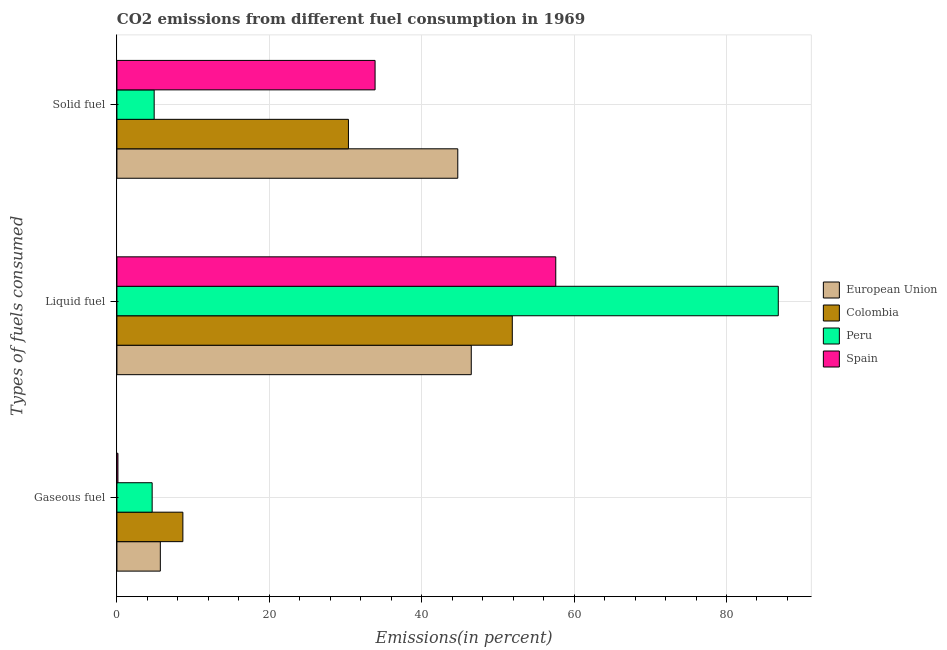How many different coloured bars are there?
Keep it short and to the point. 4. How many groups of bars are there?
Provide a short and direct response. 3. Are the number of bars on each tick of the Y-axis equal?
Your answer should be compact. Yes. How many bars are there on the 3rd tick from the top?
Make the answer very short. 4. What is the label of the 2nd group of bars from the top?
Provide a succinct answer. Liquid fuel. What is the percentage of gaseous fuel emission in European Union?
Offer a terse response. 5.7. Across all countries, what is the maximum percentage of gaseous fuel emission?
Give a very brief answer. 8.65. Across all countries, what is the minimum percentage of liquid fuel emission?
Give a very brief answer. 46.5. What is the total percentage of solid fuel emission in the graph?
Your answer should be very brief. 113.88. What is the difference between the percentage of liquid fuel emission in Colombia and that in Spain?
Provide a succinct answer. -5.7. What is the difference between the percentage of gaseous fuel emission in Colombia and the percentage of liquid fuel emission in Spain?
Provide a succinct answer. -48.94. What is the average percentage of liquid fuel emission per country?
Give a very brief answer. 60.7. What is the difference between the percentage of liquid fuel emission and percentage of gaseous fuel emission in European Union?
Provide a short and direct response. 40.81. In how many countries, is the percentage of liquid fuel emission greater than 32 %?
Give a very brief answer. 4. What is the ratio of the percentage of solid fuel emission in Colombia to that in European Union?
Make the answer very short. 0.68. Is the percentage of solid fuel emission in Peru less than that in European Union?
Your answer should be compact. Yes. What is the difference between the highest and the second highest percentage of liquid fuel emission?
Ensure brevity in your answer.  29.2. What is the difference between the highest and the lowest percentage of liquid fuel emission?
Your response must be concise. 40.29. Is the sum of the percentage of solid fuel emission in Peru and Colombia greater than the maximum percentage of gaseous fuel emission across all countries?
Your response must be concise. Yes. What does the 4th bar from the top in Liquid fuel represents?
Provide a short and direct response. European Union. What does the 1st bar from the bottom in Gaseous fuel represents?
Provide a succinct answer. European Union. Is it the case that in every country, the sum of the percentage of gaseous fuel emission and percentage of liquid fuel emission is greater than the percentage of solid fuel emission?
Offer a very short reply. Yes. Are all the bars in the graph horizontal?
Provide a short and direct response. Yes. What is the difference between two consecutive major ticks on the X-axis?
Provide a succinct answer. 20. Are the values on the major ticks of X-axis written in scientific E-notation?
Your response must be concise. No. Does the graph contain grids?
Provide a succinct answer. Yes. How many legend labels are there?
Give a very brief answer. 4. What is the title of the graph?
Provide a short and direct response. CO2 emissions from different fuel consumption in 1969. What is the label or title of the X-axis?
Ensure brevity in your answer.  Emissions(in percent). What is the label or title of the Y-axis?
Keep it short and to the point. Types of fuels consumed. What is the Emissions(in percent) of European Union in Gaseous fuel?
Provide a short and direct response. 5.7. What is the Emissions(in percent) of Colombia in Gaseous fuel?
Provide a short and direct response. 8.65. What is the Emissions(in percent) of Peru in Gaseous fuel?
Provide a short and direct response. 4.62. What is the Emissions(in percent) of Spain in Gaseous fuel?
Provide a short and direct response. 0.13. What is the Emissions(in percent) of European Union in Liquid fuel?
Ensure brevity in your answer.  46.5. What is the Emissions(in percent) of Colombia in Liquid fuel?
Make the answer very short. 51.89. What is the Emissions(in percent) in Peru in Liquid fuel?
Offer a terse response. 86.8. What is the Emissions(in percent) of Spain in Liquid fuel?
Provide a succinct answer. 57.59. What is the Emissions(in percent) in European Union in Solid fuel?
Offer a very short reply. 44.73. What is the Emissions(in percent) in Colombia in Solid fuel?
Keep it short and to the point. 30.38. What is the Emissions(in percent) in Peru in Solid fuel?
Your response must be concise. 4.89. What is the Emissions(in percent) in Spain in Solid fuel?
Offer a very short reply. 33.88. Across all Types of fuels consumed, what is the maximum Emissions(in percent) in European Union?
Your answer should be compact. 46.5. Across all Types of fuels consumed, what is the maximum Emissions(in percent) of Colombia?
Offer a terse response. 51.89. Across all Types of fuels consumed, what is the maximum Emissions(in percent) of Peru?
Provide a succinct answer. 86.8. Across all Types of fuels consumed, what is the maximum Emissions(in percent) of Spain?
Offer a very short reply. 57.59. Across all Types of fuels consumed, what is the minimum Emissions(in percent) of European Union?
Provide a succinct answer. 5.7. Across all Types of fuels consumed, what is the minimum Emissions(in percent) in Colombia?
Your response must be concise. 8.65. Across all Types of fuels consumed, what is the minimum Emissions(in percent) in Peru?
Provide a succinct answer. 4.62. Across all Types of fuels consumed, what is the minimum Emissions(in percent) in Spain?
Provide a short and direct response. 0.13. What is the total Emissions(in percent) of European Union in the graph?
Your answer should be compact. 96.93. What is the total Emissions(in percent) of Colombia in the graph?
Your answer should be compact. 90.93. What is the total Emissions(in percent) in Peru in the graph?
Ensure brevity in your answer.  96.31. What is the total Emissions(in percent) in Spain in the graph?
Offer a terse response. 91.6. What is the difference between the Emissions(in percent) of European Union in Gaseous fuel and that in Liquid fuel?
Your response must be concise. -40.81. What is the difference between the Emissions(in percent) in Colombia in Gaseous fuel and that in Liquid fuel?
Offer a terse response. -43.23. What is the difference between the Emissions(in percent) of Peru in Gaseous fuel and that in Liquid fuel?
Offer a very short reply. -82.17. What is the difference between the Emissions(in percent) of Spain in Gaseous fuel and that in Liquid fuel?
Provide a succinct answer. -57.46. What is the difference between the Emissions(in percent) in European Union in Gaseous fuel and that in Solid fuel?
Provide a succinct answer. -39.04. What is the difference between the Emissions(in percent) in Colombia in Gaseous fuel and that in Solid fuel?
Your response must be concise. -21.73. What is the difference between the Emissions(in percent) in Peru in Gaseous fuel and that in Solid fuel?
Offer a terse response. -0.26. What is the difference between the Emissions(in percent) of Spain in Gaseous fuel and that in Solid fuel?
Your response must be concise. -33.75. What is the difference between the Emissions(in percent) in European Union in Liquid fuel and that in Solid fuel?
Your answer should be very brief. 1.77. What is the difference between the Emissions(in percent) in Colombia in Liquid fuel and that in Solid fuel?
Offer a very short reply. 21.51. What is the difference between the Emissions(in percent) in Peru in Liquid fuel and that in Solid fuel?
Your answer should be compact. 81.91. What is the difference between the Emissions(in percent) of Spain in Liquid fuel and that in Solid fuel?
Your answer should be very brief. 23.71. What is the difference between the Emissions(in percent) in European Union in Gaseous fuel and the Emissions(in percent) in Colombia in Liquid fuel?
Keep it short and to the point. -46.19. What is the difference between the Emissions(in percent) in European Union in Gaseous fuel and the Emissions(in percent) in Peru in Liquid fuel?
Provide a succinct answer. -81.1. What is the difference between the Emissions(in percent) in European Union in Gaseous fuel and the Emissions(in percent) in Spain in Liquid fuel?
Make the answer very short. -51.9. What is the difference between the Emissions(in percent) of Colombia in Gaseous fuel and the Emissions(in percent) of Peru in Liquid fuel?
Ensure brevity in your answer.  -78.14. What is the difference between the Emissions(in percent) in Colombia in Gaseous fuel and the Emissions(in percent) in Spain in Liquid fuel?
Your answer should be very brief. -48.94. What is the difference between the Emissions(in percent) of Peru in Gaseous fuel and the Emissions(in percent) of Spain in Liquid fuel?
Keep it short and to the point. -52.97. What is the difference between the Emissions(in percent) in European Union in Gaseous fuel and the Emissions(in percent) in Colombia in Solid fuel?
Ensure brevity in your answer.  -24.69. What is the difference between the Emissions(in percent) of European Union in Gaseous fuel and the Emissions(in percent) of Peru in Solid fuel?
Offer a very short reply. 0.81. What is the difference between the Emissions(in percent) of European Union in Gaseous fuel and the Emissions(in percent) of Spain in Solid fuel?
Offer a very short reply. -28.18. What is the difference between the Emissions(in percent) in Colombia in Gaseous fuel and the Emissions(in percent) in Peru in Solid fuel?
Make the answer very short. 3.77. What is the difference between the Emissions(in percent) of Colombia in Gaseous fuel and the Emissions(in percent) of Spain in Solid fuel?
Keep it short and to the point. -25.22. What is the difference between the Emissions(in percent) in Peru in Gaseous fuel and the Emissions(in percent) in Spain in Solid fuel?
Make the answer very short. -29.25. What is the difference between the Emissions(in percent) in European Union in Liquid fuel and the Emissions(in percent) in Colombia in Solid fuel?
Offer a terse response. 16.12. What is the difference between the Emissions(in percent) of European Union in Liquid fuel and the Emissions(in percent) of Peru in Solid fuel?
Offer a terse response. 41.62. What is the difference between the Emissions(in percent) of European Union in Liquid fuel and the Emissions(in percent) of Spain in Solid fuel?
Offer a terse response. 12.62. What is the difference between the Emissions(in percent) of Colombia in Liquid fuel and the Emissions(in percent) of Peru in Solid fuel?
Give a very brief answer. 47. What is the difference between the Emissions(in percent) in Colombia in Liquid fuel and the Emissions(in percent) in Spain in Solid fuel?
Ensure brevity in your answer.  18.01. What is the difference between the Emissions(in percent) of Peru in Liquid fuel and the Emissions(in percent) of Spain in Solid fuel?
Keep it short and to the point. 52.92. What is the average Emissions(in percent) of European Union per Types of fuels consumed?
Keep it short and to the point. 32.31. What is the average Emissions(in percent) in Colombia per Types of fuels consumed?
Keep it short and to the point. 30.31. What is the average Emissions(in percent) of Peru per Types of fuels consumed?
Offer a very short reply. 32.1. What is the average Emissions(in percent) in Spain per Types of fuels consumed?
Provide a succinct answer. 30.53. What is the difference between the Emissions(in percent) of European Union and Emissions(in percent) of Colombia in Gaseous fuel?
Ensure brevity in your answer.  -2.96. What is the difference between the Emissions(in percent) in European Union and Emissions(in percent) in Peru in Gaseous fuel?
Provide a succinct answer. 1.07. What is the difference between the Emissions(in percent) of European Union and Emissions(in percent) of Spain in Gaseous fuel?
Give a very brief answer. 5.56. What is the difference between the Emissions(in percent) of Colombia and Emissions(in percent) of Peru in Gaseous fuel?
Your answer should be compact. 4.03. What is the difference between the Emissions(in percent) of Colombia and Emissions(in percent) of Spain in Gaseous fuel?
Provide a short and direct response. 8.52. What is the difference between the Emissions(in percent) of Peru and Emissions(in percent) of Spain in Gaseous fuel?
Your answer should be compact. 4.49. What is the difference between the Emissions(in percent) of European Union and Emissions(in percent) of Colombia in Liquid fuel?
Your response must be concise. -5.38. What is the difference between the Emissions(in percent) in European Union and Emissions(in percent) in Peru in Liquid fuel?
Offer a terse response. -40.29. What is the difference between the Emissions(in percent) in European Union and Emissions(in percent) in Spain in Liquid fuel?
Make the answer very short. -11.09. What is the difference between the Emissions(in percent) in Colombia and Emissions(in percent) in Peru in Liquid fuel?
Keep it short and to the point. -34.91. What is the difference between the Emissions(in percent) in Colombia and Emissions(in percent) in Spain in Liquid fuel?
Your answer should be very brief. -5.7. What is the difference between the Emissions(in percent) in Peru and Emissions(in percent) in Spain in Liquid fuel?
Provide a succinct answer. 29.2. What is the difference between the Emissions(in percent) in European Union and Emissions(in percent) in Colombia in Solid fuel?
Ensure brevity in your answer.  14.35. What is the difference between the Emissions(in percent) of European Union and Emissions(in percent) of Peru in Solid fuel?
Keep it short and to the point. 39.84. What is the difference between the Emissions(in percent) in European Union and Emissions(in percent) in Spain in Solid fuel?
Your answer should be very brief. 10.85. What is the difference between the Emissions(in percent) of Colombia and Emissions(in percent) of Peru in Solid fuel?
Provide a succinct answer. 25.49. What is the difference between the Emissions(in percent) in Colombia and Emissions(in percent) in Spain in Solid fuel?
Offer a terse response. -3.5. What is the difference between the Emissions(in percent) of Peru and Emissions(in percent) of Spain in Solid fuel?
Ensure brevity in your answer.  -28.99. What is the ratio of the Emissions(in percent) in European Union in Gaseous fuel to that in Liquid fuel?
Make the answer very short. 0.12. What is the ratio of the Emissions(in percent) in Colombia in Gaseous fuel to that in Liquid fuel?
Offer a terse response. 0.17. What is the ratio of the Emissions(in percent) of Peru in Gaseous fuel to that in Liquid fuel?
Provide a short and direct response. 0.05. What is the ratio of the Emissions(in percent) in Spain in Gaseous fuel to that in Liquid fuel?
Your response must be concise. 0. What is the ratio of the Emissions(in percent) of European Union in Gaseous fuel to that in Solid fuel?
Your response must be concise. 0.13. What is the ratio of the Emissions(in percent) in Colombia in Gaseous fuel to that in Solid fuel?
Keep it short and to the point. 0.28. What is the ratio of the Emissions(in percent) in Peru in Gaseous fuel to that in Solid fuel?
Offer a terse response. 0.95. What is the ratio of the Emissions(in percent) in Spain in Gaseous fuel to that in Solid fuel?
Keep it short and to the point. 0. What is the ratio of the Emissions(in percent) of European Union in Liquid fuel to that in Solid fuel?
Provide a succinct answer. 1.04. What is the ratio of the Emissions(in percent) in Colombia in Liquid fuel to that in Solid fuel?
Your answer should be very brief. 1.71. What is the ratio of the Emissions(in percent) of Peru in Liquid fuel to that in Solid fuel?
Provide a short and direct response. 17.75. What is the ratio of the Emissions(in percent) of Spain in Liquid fuel to that in Solid fuel?
Give a very brief answer. 1.7. What is the difference between the highest and the second highest Emissions(in percent) of European Union?
Give a very brief answer. 1.77. What is the difference between the highest and the second highest Emissions(in percent) in Colombia?
Provide a short and direct response. 21.51. What is the difference between the highest and the second highest Emissions(in percent) in Peru?
Provide a short and direct response. 81.91. What is the difference between the highest and the second highest Emissions(in percent) in Spain?
Give a very brief answer. 23.71. What is the difference between the highest and the lowest Emissions(in percent) of European Union?
Provide a short and direct response. 40.81. What is the difference between the highest and the lowest Emissions(in percent) in Colombia?
Make the answer very short. 43.23. What is the difference between the highest and the lowest Emissions(in percent) in Peru?
Give a very brief answer. 82.17. What is the difference between the highest and the lowest Emissions(in percent) in Spain?
Ensure brevity in your answer.  57.46. 